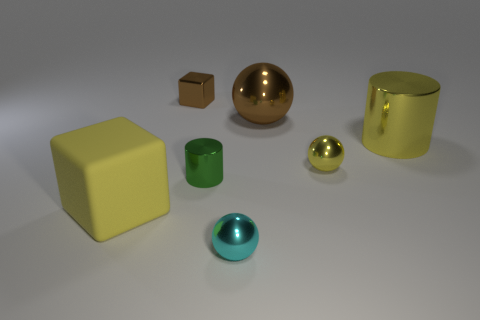What is the material of the small object that is the same color as the big matte cube?
Ensure brevity in your answer.  Metal. The rubber object that is the same color as the large cylinder is what shape?
Your response must be concise. Cube. How many cubes are either purple metallic objects or brown things?
Your response must be concise. 1. Is the number of large cubes behind the large brown sphere the same as the number of spheres that are behind the yellow block?
Make the answer very short. No. The brown metal object that is the same shape as the tiny yellow thing is what size?
Ensure brevity in your answer.  Large. What size is the shiny object that is behind the yellow cylinder and to the right of the small brown object?
Give a very brief answer. Large. Are there any big spheres behind the yellow sphere?
Give a very brief answer. Yes. How many things are either large yellow objects that are behind the large yellow rubber block or large balls?
Ensure brevity in your answer.  2. There is a small thing behind the large metal cylinder; what number of metal things are behind it?
Provide a short and direct response. 0. Are there fewer shiny balls behind the green cylinder than tiny metallic objects to the left of the small yellow sphere?
Offer a very short reply. Yes. 